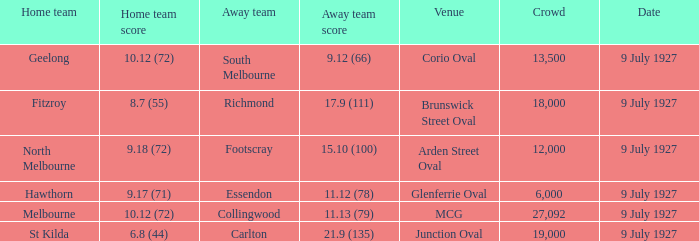What was the venue where Fitzroy played as the home team? Brunswick Street Oval. 